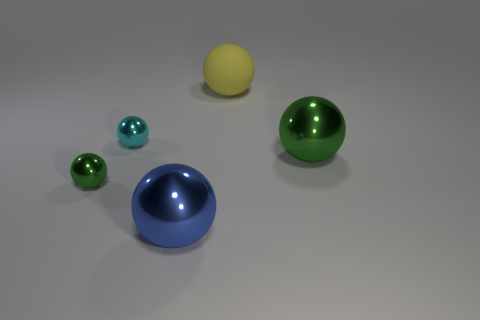What size is the blue metallic object that is the same shape as the yellow rubber thing?
Offer a terse response. Large. How big is the metal object that is behind the small green object and on the right side of the cyan metal thing?
Make the answer very short. Large. The large rubber thing has what color?
Provide a succinct answer. Yellow. There is a blue thing that is in front of the large yellow thing; what is its size?
Keep it short and to the point. Large. What number of small cyan things are right of the green ball on the right side of the tiny shiny thing that is in front of the tiny cyan ball?
Provide a short and direct response. 0. What color is the tiny object behind the green object right of the small cyan ball?
Offer a terse response. Cyan. Are there any cyan spheres that have the same size as the blue object?
Your answer should be very brief. No. There is a large thing that is behind the green object that is right of the big shiny thing that is to the left of the matte sphere; what is it made of?
Give a very brief answer. Rubber. How many green shiny balls are on the right side of the small shiny object behind the large green ball?
Your answer should be compact. 1. There is a cyan shiny sphere on the left side of the yellow ball; is its size the same as the tiny green sphere?
Keep it short and to the point. Yes. 